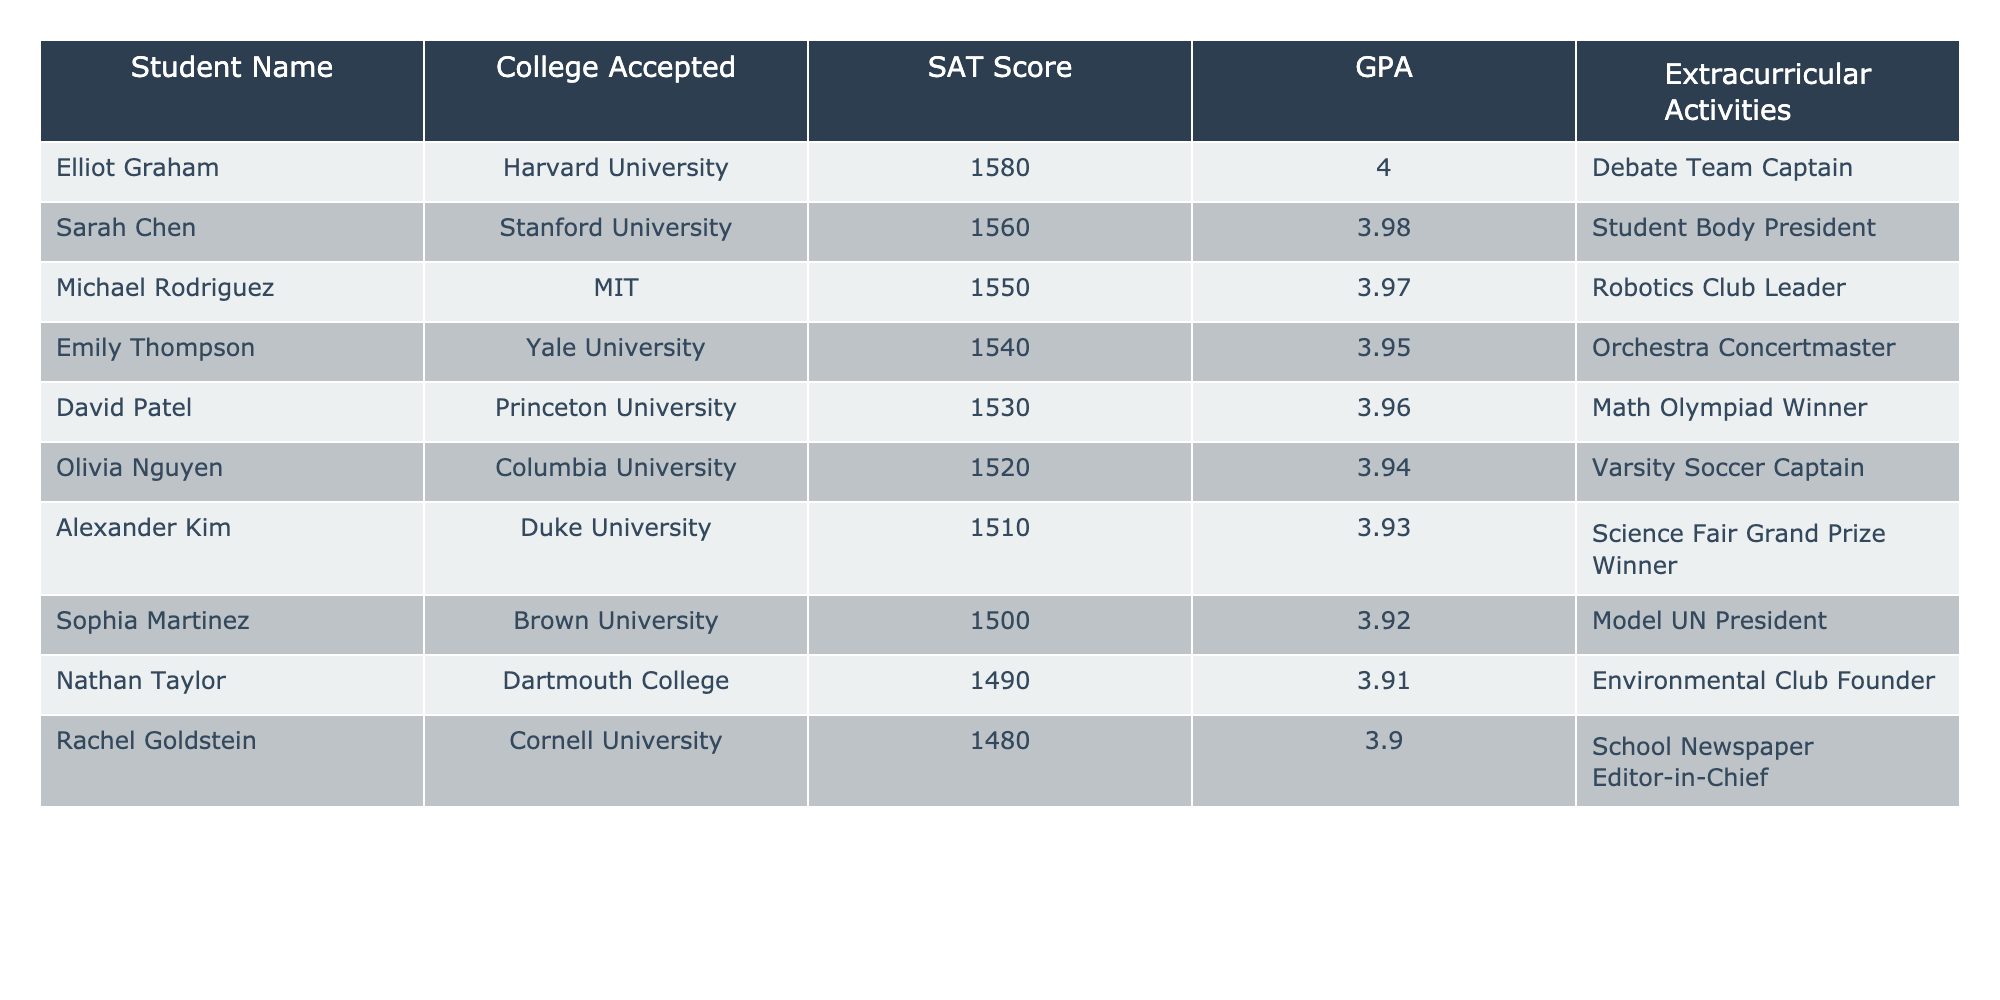What college is Elliot Graham accepted to? The table lists Elliot Graham's acceptance information, showing that he was accepted to Harvard University.
Answer: Harvard University What is the SAT score of the student with the highest GPA? By reviewing the table, Michael Rodriguez has the highest GPA of 3.97 with an SAT score of 1550.
Answer: 1550 How many students have a GPA higher than 3.90? The students with GPAs higher than 3.90 are Elliot Graham (4.0), Sarah Chen (3.98), Michael Rodriguez (3.97), Emily Thompson (3.95), and David Patel (3.96). There are 5 students in total.
Answer: 5 Which college did the student with the lowest SAT score attend? The lowest SAT score listed is 1480, which belongs to Rachel Goldstein; she was accepted to Cornell University.
Answer: Cornell University What is the average SAT score of the students listed in the table? To find the average SAT score, sum the SAT scores: 1580 + 1560 + 1550 + 1540 + 1530 + 1520 + 1510 + 1500 + 1490 + 1480 = 1530. Then divide by the total number of students (10): 15300 / 10 = 1530.
Answer: 1530 Is there a student who is both a captain of a varsity sports team and has a GPA above 3.90? Looking at the table, the only student recognized as a varsity sports captain is Olivia Nguyen, with a GPA of 3.94, which is above 3.90. Thus, the answer is yes.
Answer: Yes What is the difference between the highest and lowest GPA in the table? Elliot Graham has the highest GPA at 4.0, and Rachel Goldstein has the lowest at 3.90. To find the difference: 4.0 - 3.90 = 0.10.
Answer: 0.10 Which extracurricular activity is associated with the student who has the second highest SAT score? The student with the second highest SAT score is Sarah Chen, who is the Student Body President.
Answer: Student Body President How many students were accepted to Ivy League colleges? The Ivy League colleges in the list are Harvard, Yale, Princeton, and Cornell. Thus, 4 students were accepted to Ivy League institutions.
Answer: 4 Which student is a Debate Team Captain? Reviewing the table shows that Elliot Graham serves as the Debate Team Captain.
Answer: Elliot Graham 